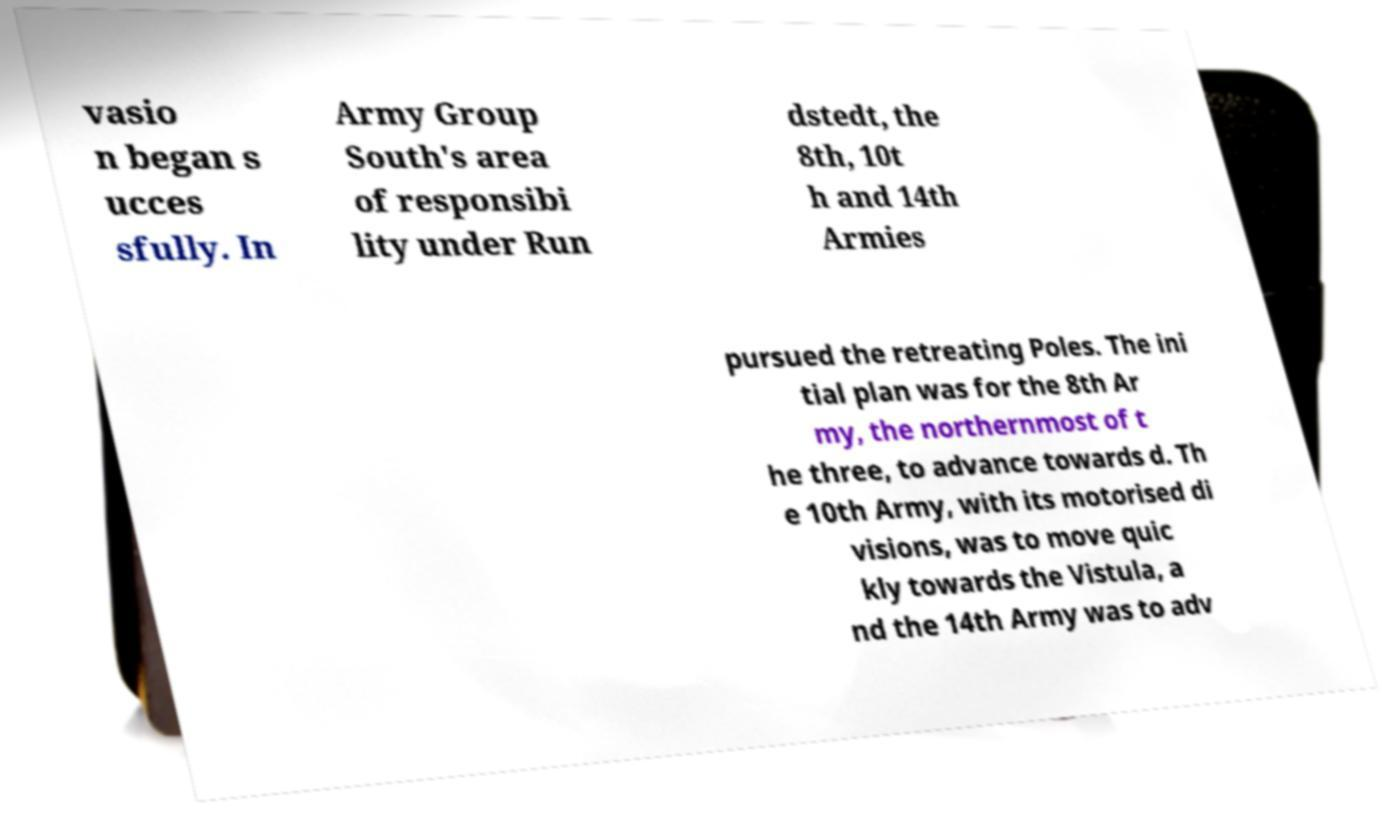Please identify and transcribe the text found in this image. vasio n began s ucces sfully. In Army Group South's area of responsibi lity under Run dstedt, the 8th, 10t h and 14th Armies pursued the retreating Poles. The ini tial plan was for the 8th Ar my, the northernmost of t he three, to advance towards d. Th e 10th Army, with its motorised di visions, was to move quic kly towards the Vistula, a nd the 14th Army was to adv 